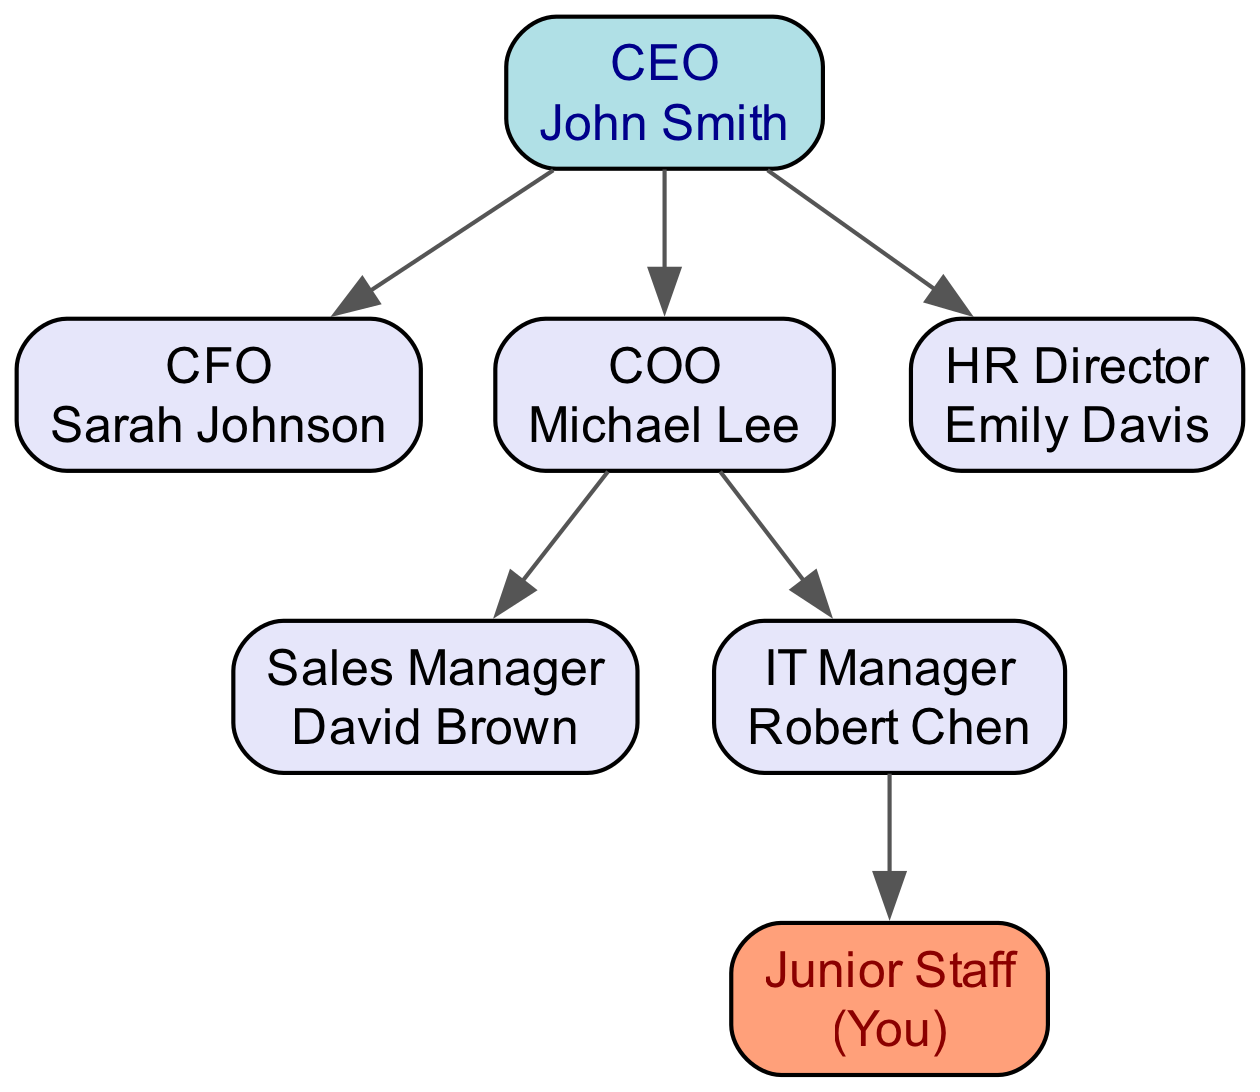What is the title of the person who reports directly to the CEO? The diagram shows that the CEO has direct reports, which include the CFO, COO, and HR Director. The titles of these individuals can be found next to their names in the nodes. For instance, one title is "CFO" next to "Sarah Johnson."
Answer: CFO Who reports to the COO? Looking at the diagram's edges, the COO has two direct reports: the Sales Manager and the IT Manager. Both of their positions are marked with lines extending from the COO node to their respective nodes.
Answer: Sales Manager and IT Manager How many nodes are present in the organizational chart? The total number of nodes can be counted directly from the list in the data provided, which includes the CEO, CFO, COO, HR, Sales, IT, and Junior Staff. Counting these gives a total of 7 nodes.
Answer: 7 What is the relationship between the IT Manager and Junior Staff? The diagram shows an edge connecting the IT Manager to the Junior Staff, indicating a direct reporting relationship. This means the Junior Staff reports to the IT Manager.
Answer: Junior Staff reports to IT Manager If Sarah Johnson left the company, who would take over her responsibilities? To determine the potential successor, one can analyze the hierarchy. Since the CFO is a direct report to the CEO and there is no clear second-in-command in this context, the responsibilities would likely remain with the CEO until a new CFO is appointed.
Answer: CEO Which department does the Junior Staff belong to? By analyzing the reporting structure, we see that the Junior Staff is directly subordinate to the IT Manager. Thus, this indicates that the Junior Staff belongs to the IT department.
Answer: IT department How many edges connect the nodes in this chart? To find the number of edges, one can count the connections made between the various nodes. In this chart, there are six edges connecting the nodes based on the relationships outlined in the diagram data.
Answer: 6 Who is the highest-ranking individual in this organizational chart? The CEO is positioned at the top of the hierarchy, as indicated in the diagram by having arrows pointing from several nodes to the CEO. This establishes that the CEO is the highest-ranking individual in the organization.
Answer: CEO 